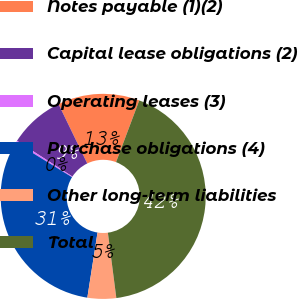Convert chart. <chart><loc_0><loc_0><loc_500><loc_500><pie_chart><fcel>Notes payable (1)(2)<fcel>Capital lease obligations (2)<fcel>Operating leases (3)<fcel>Purchase obligations (4)<fcel>Other long-term liabilities<fcel>Total<nl><fcel>12.9%<fcel>8.71%<fcel>0.33%<fcel>31.32%<fcel>4.52%<fcel>42.23%<nl></chart> 